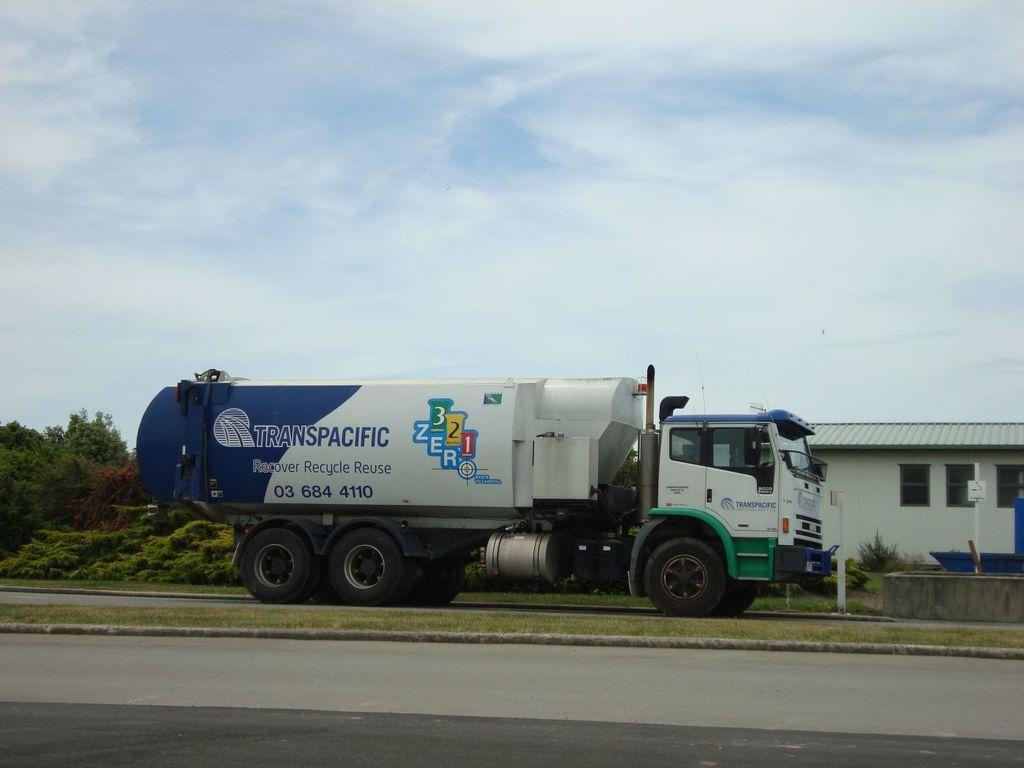Can you describe this image briefly? In this picture in the middle, we can see a vehicle moving on the road. On the right side, we can see a building, pole, plants. On the left side, we can also see some trees. On the top, we can see a sky which is cloudy, at the bottom there is a grass and a road. 